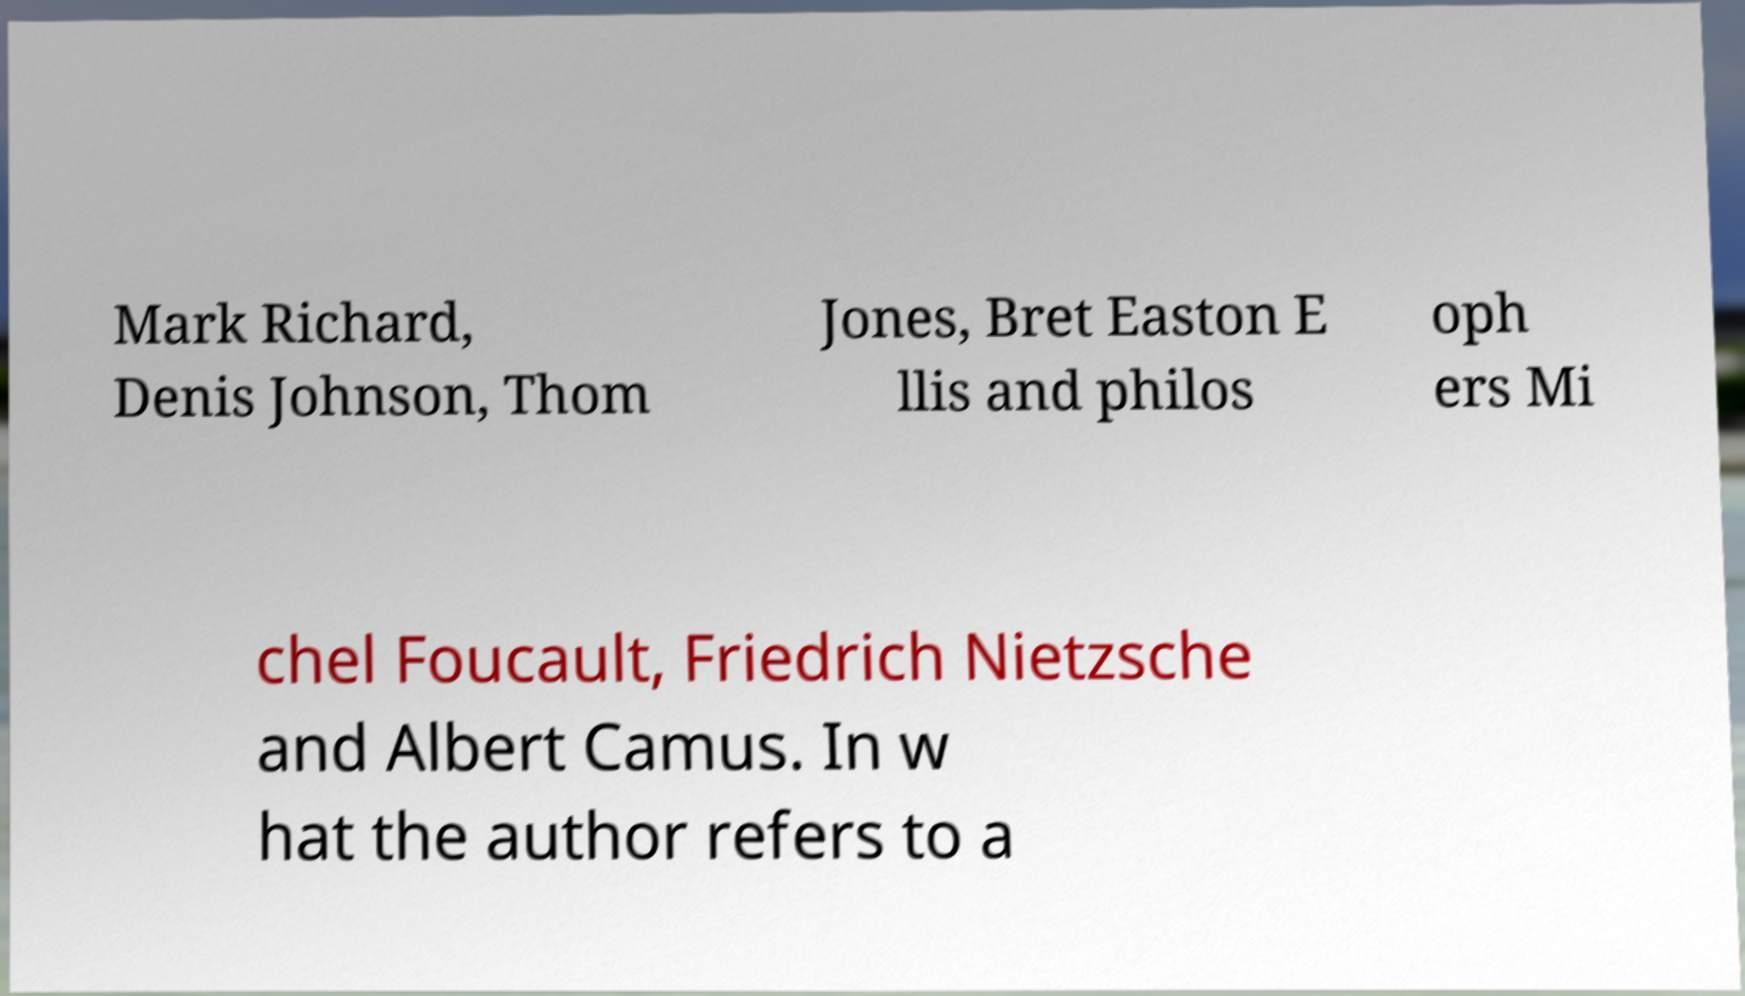What messages or text are displayed in this image? I need them in a readable, typed format. Mark Richard, Denis Johnson, Thom Jones, Bret Easton E llis and philos oph ers Mi chel Foucault, Friedrich Nietzsche and Albert Camus. In w hat the author refers to a 